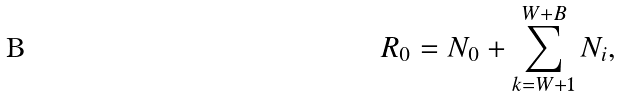<formula> <loc_0><loc_0><loc_500><loc_500>R _ { 0 } = N _ { 0 } + \sum _ { k = W + 1 } ^ { W + B } N _ { i } ,</formula> 